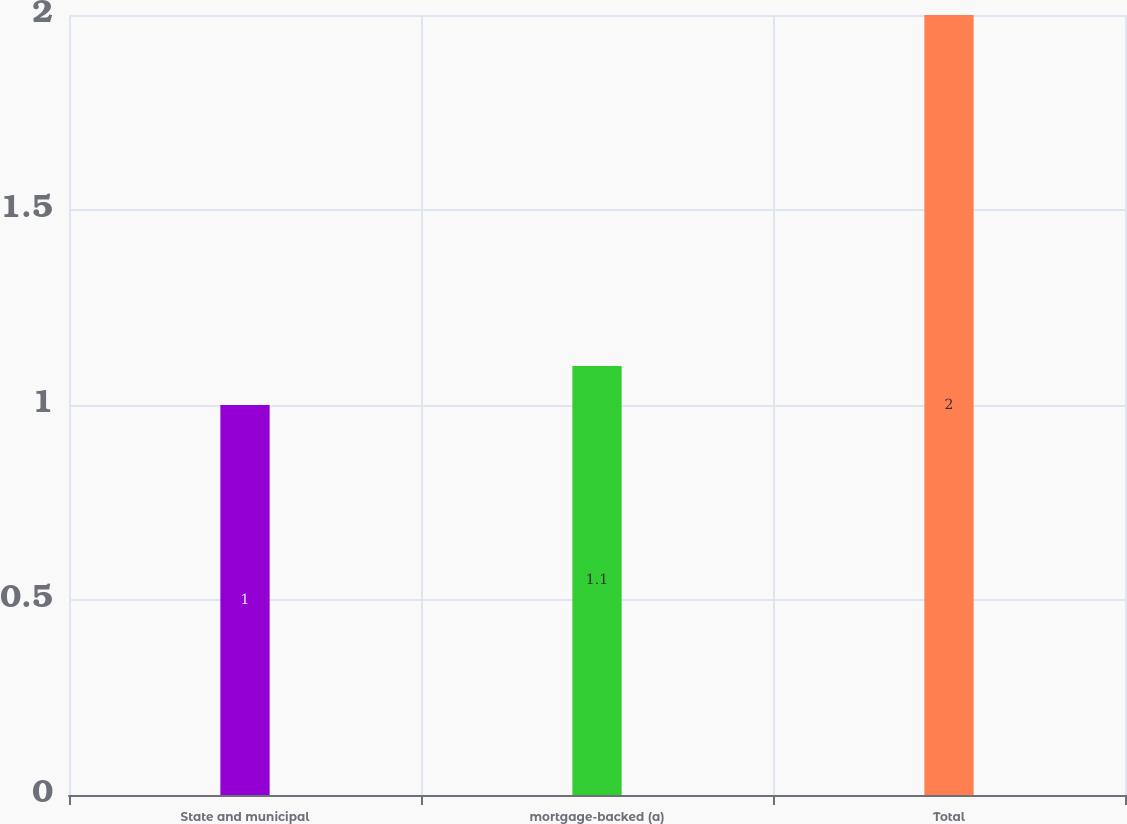Convert chart. <chart><loc_0><loc_0><loc_500><loc_500><bar_chart><fcel>State and municipal<fcel>mortgage-backed (a)<fcel>Total<nl><fcel>1<fcel>1.1<fcel>2<nl></chart> 